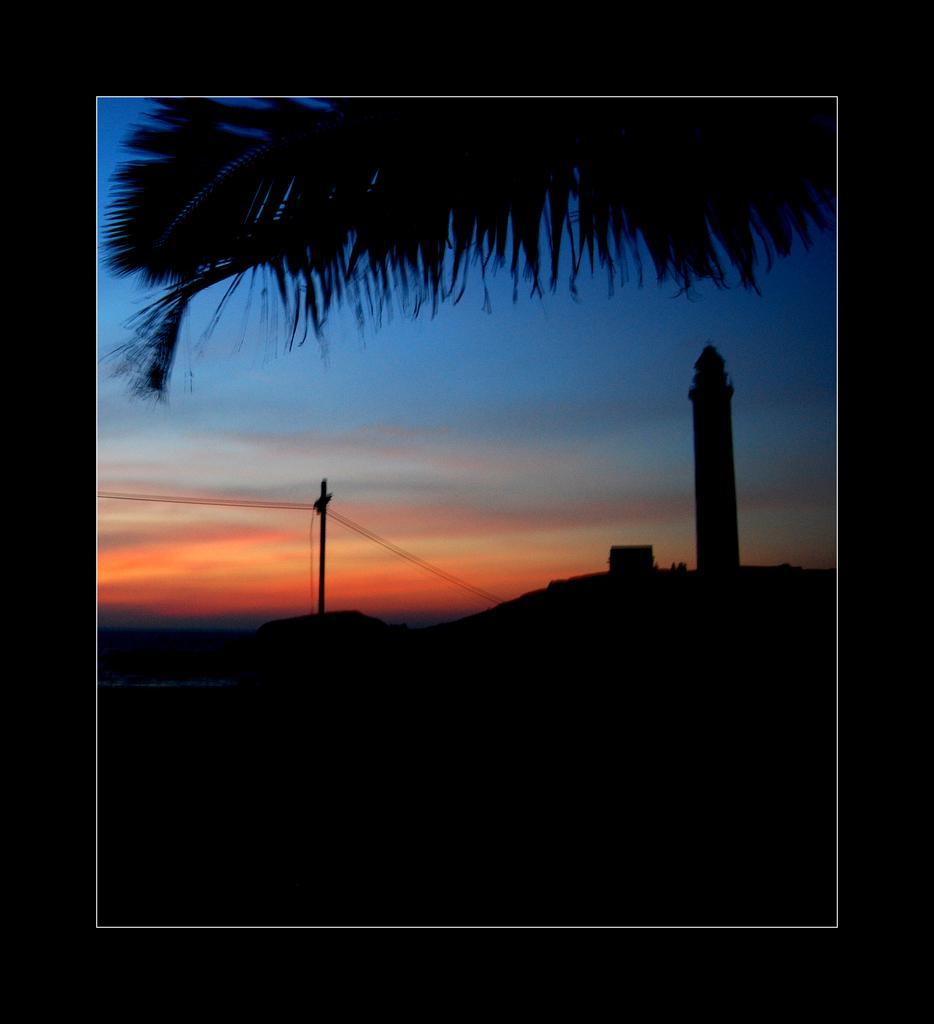Please provide a concise description of this image. In this picture there is a sunset photography. In the front there is a tower and red color sky. Above we can see the huge coconut leave. 